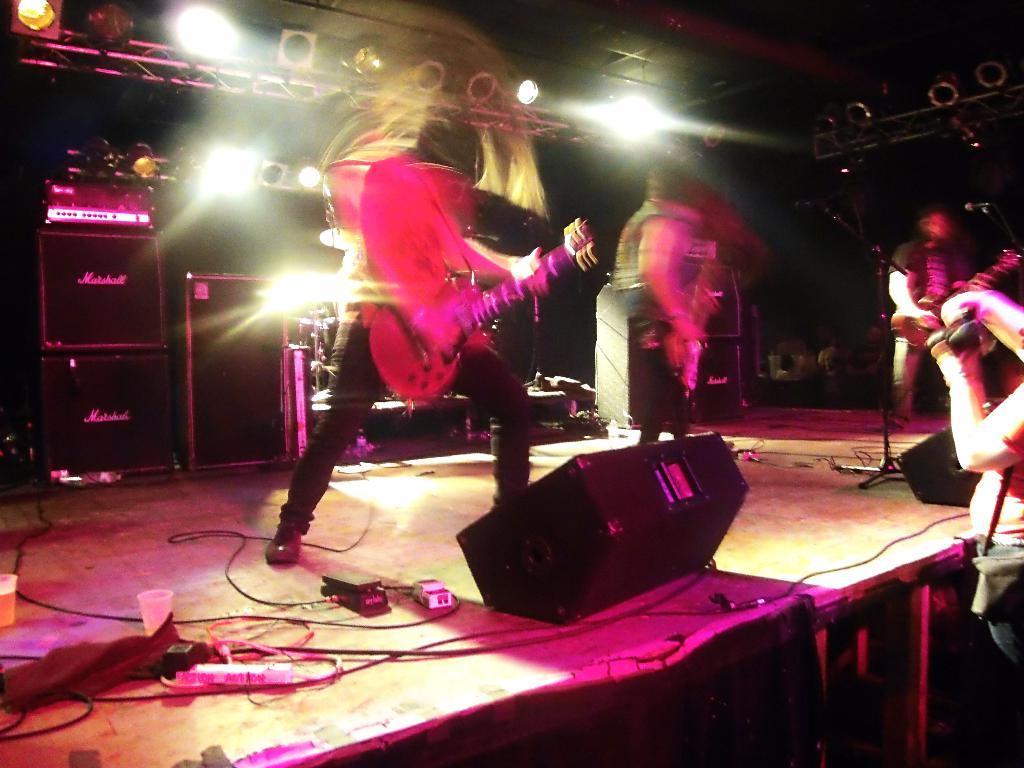Could you give a brief overview of what you see in this image? This picture shows a few people performing on the dais and we see few of them holding guitars in their hands and we see a human standing and we see speakers on the floor and drums on the back and we see lights to the roof. 